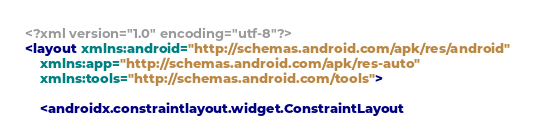<code> <loc_0><loc_0><loc_500><loc_500><_XML_><?xml version="1.0" encoding="utf-8"?>
<layout xmlns:android="http://schemas.android.com/apk/res/android"
    xmlns:app="http://schemas.android.com/apk/res-auto"
    xmlns:tools="http://schemas.android.com/tools">

    <androidx.constraintlayout.widget.ConstraintLayout</code> 